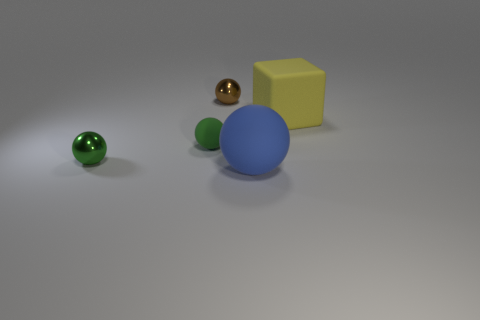Are there the same number of matte balls that are left of the green metallic thing and big blue rubber objects?
Keep it short and to the point. No. Is there anything else that is the same material as the cube?
Offer a terse response. Yes. How many large things are either brown objects or blue things?
Offer a very short reply. 1. Is the material of the thing that is behind the yellow matte thing the same as the yellow object?
Offer a very short reply. No. The ball to the right of the tiny metallic ball that is behind the cube is made of what material?
Provide a succinct answer. Rubber. What number of green objects are the same shape as the tiny brown thing?
Provide a succinct answer. 2. There is a metallic thing in front of the thing that is behind the big thing that is on the right side of the big blue matte sphere; what size is it?
Keep it short and to the point. Small. What number of yellow things are either matte cubes or small objects?
Give a very brief answer. 1. There is a rubber object right of the big blue thing; is it the same shape as the tiny rubber thing?
Offer a terse response. No. Are there more cubes on the left side of the small green matte sphere than brown spheres?
Make the answer very short. No. 